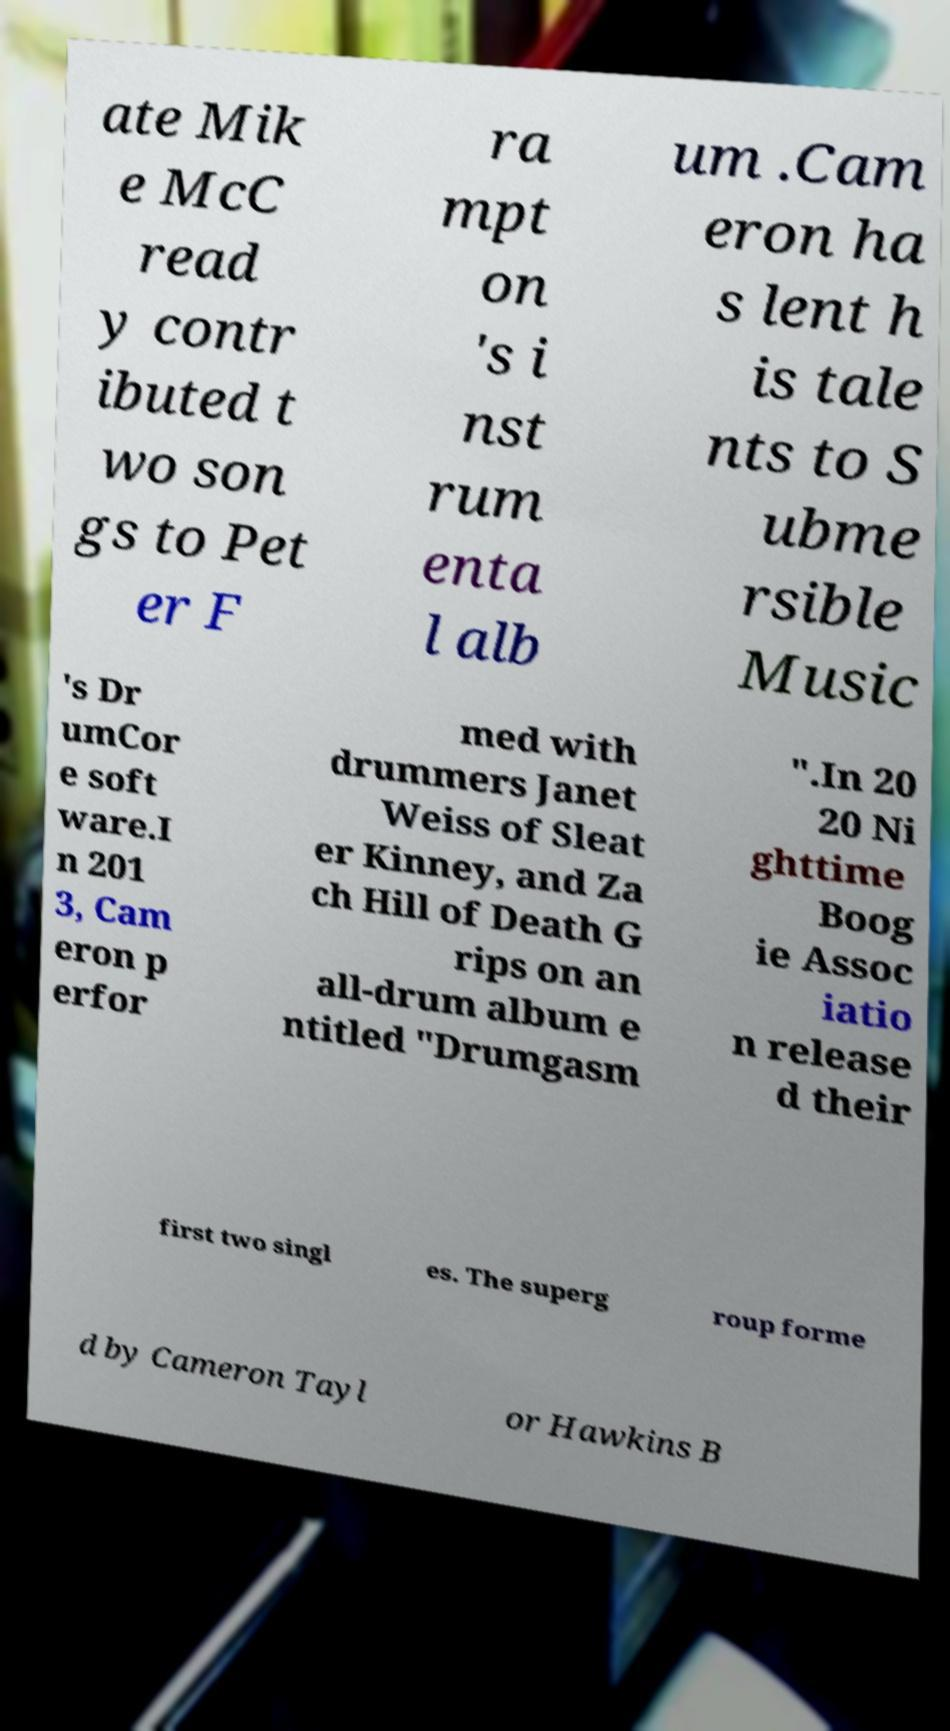I need the written content from this picture converted into text. Can you do that? ate Mik e McC read y contr ibuted t wo son gs to Pet er F ra mpt on 's i nst rum enta l alb um .Cam eron ha s lent h is tale nts to S ubme rsible Music 's Dr umCor e soft ware.I n 201 3, Cam eron p erfor med with drummers Janet Weiss of Sleat er Kinney, and Za ch Hill of Death G rips on an all-drum album e ntitled "Drumgasm ".In 20 20 Ni ghttime Boog ie Assoc iatio n release d their first two singl es. The superg roup forme d by Cameron Tayl or Hawkins B 